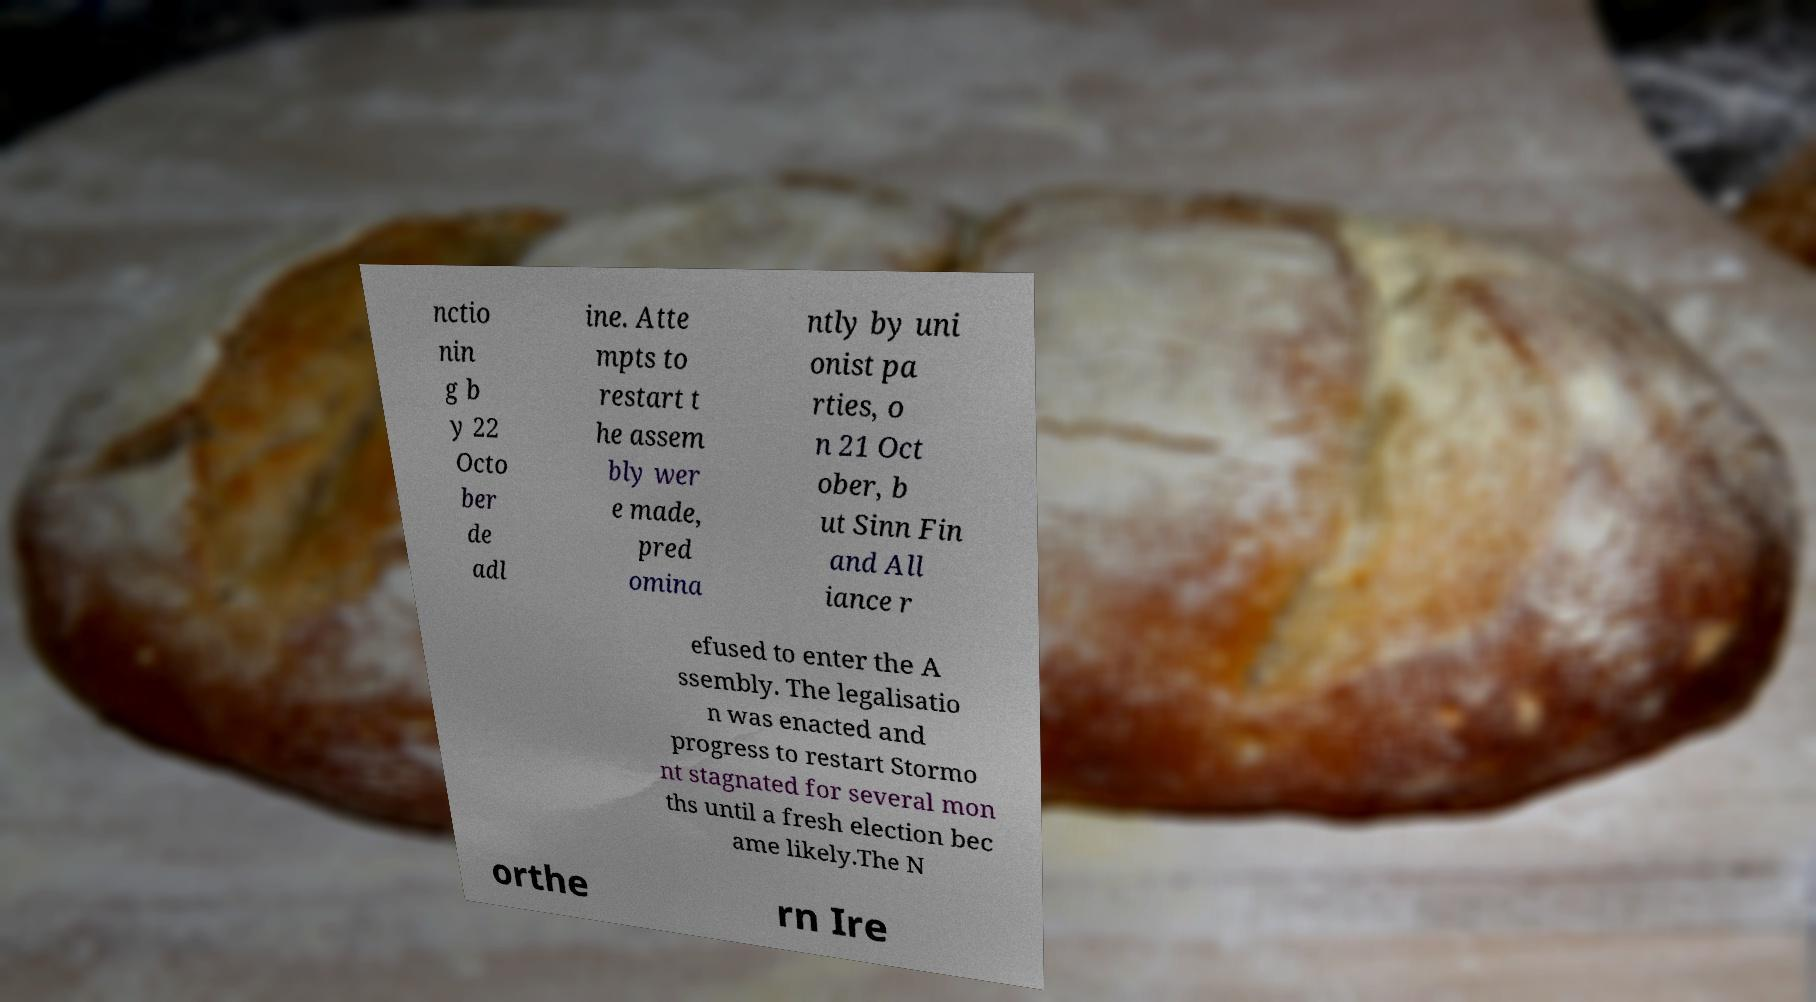What messages or text are displayed in this image? I need them in a readable, typed format. nctio nin g b y 22 Octo ber de adl ine. Atte mpts to restart t he assem bly wer e made, pred omina ntly by uni onist pa rties, o n 21 Oct ober, b ut Sinn Fin and All iance r efused to enter the A ssembly. The legalisatio n was enacted and progress to restart Stormo nt stagnated for several mon ths until a fresh election bec ame likely.The N orthe rn Ire 